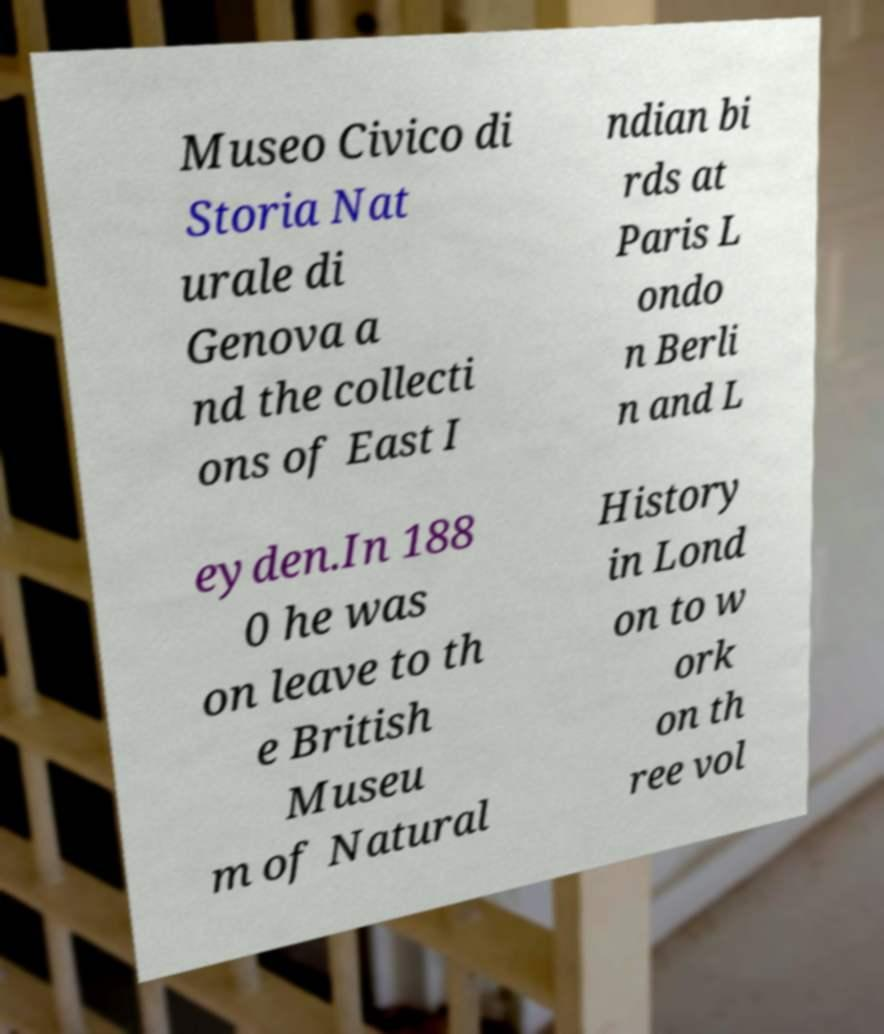Can you read and provide the text displayed in the image?This photo seems to have some interesting text. Can you extract and type it out for me? Museo Civico di Storia Nat urale di Genova a nd the collecti ons of East I ndian bi rds at Paris L ondo n Berli n and L eyden.In 188 0 he was on leave to th e British Museu m of Natural History in Lond on to w ork on th ree vol 